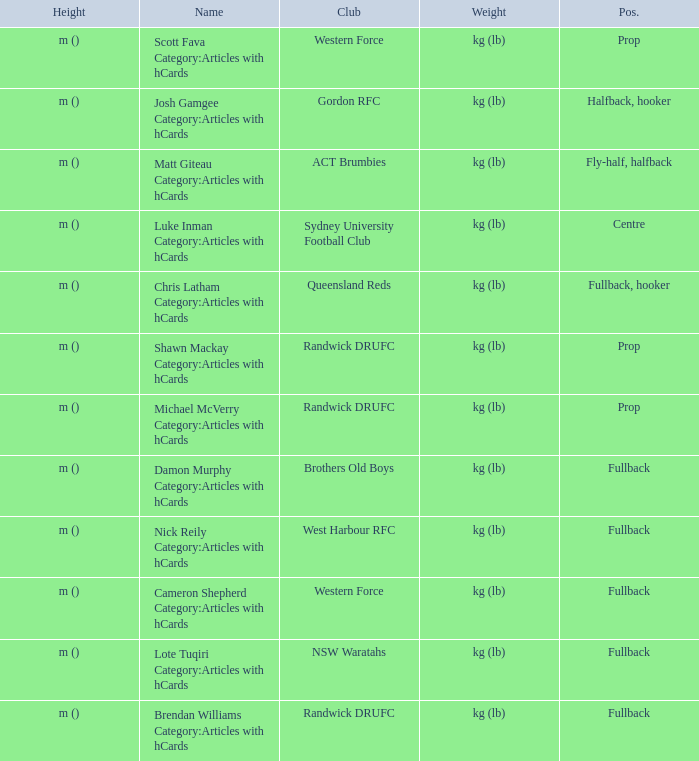What is the name when the position is centre? Luke Inman Category:Articles with hCards. 